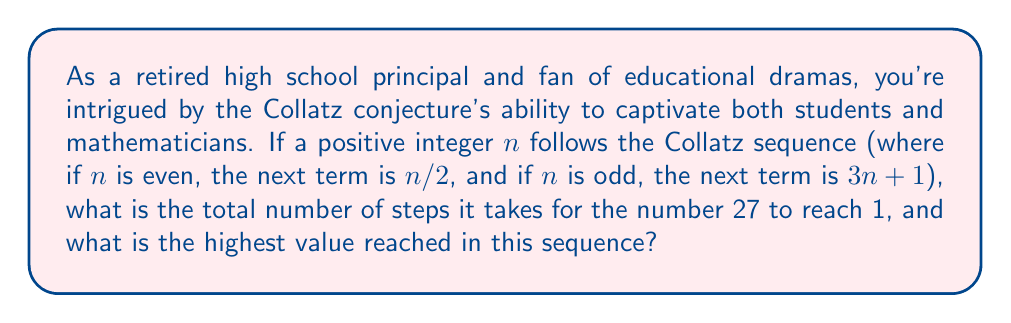Solve this math problem. Let's work through the Collatz sequence for 27:

1) Start with $n = 27$ (odd)
2) $3n + 1 = 3(27) + 1 = 82$
3) $82/2 = 41$ (even)
4) $3(41) + 1 = 124$
5) $124/2 = 62$
6) $62/2 = 31$
7) $3(31) + 1 = 94$
8) $94/2 = 47$
9) $3(47) + 1 = 142$
10) $142/2 = 71$
11) $3(71) + 1 = 214$
12) $214/2 = 107$
13) $3(107) + 1 = 322$
14) $322/2 = 161$
15) $3(161) + 1 = 484$
16) $484/2 = 242$
17) $242/2 = 121$
18) $3(121) + 1 = 364$
19) $364/2 = 182$
20) $182/2 = 91$
21) $3(91) + 1 = 274$
22) $274/2 = 137$
23) $3(137) + 1 = 412$
24) $412/2 = 206$
25) $206/2 = 103$
26) $3(103) + 1 = 310$
27) $310/2 = 155$
28) $3(155) + 1 = 466$
29) $466/2 = 233$
30) $3(233) + 1 = 700$
31) $700/2 = 350$
32) $350/2 = 175$
33) $3(175) + 1 = 526$
34) $526/2 = 263$
35) $3(263) + 1 = 790$
36) $790/2 = 395$
37) $3(395) + 1 = 1186$
38) $1186/2 = 593$
39) $3(593) + 1 = 1780$
40) $1780/2 = 890$
41) $890/2 = 445$
42) $3(445) + 1 = 1336$
43) $1336/2 = 668$
44) $668/2 = 334$
45) $334/2 = 167$
46) $3(167) + 1 = 502$
47) $502/2 = 251$
48) $3(251) + 1 = 754$
49) $754/2 = 377$
50) $3(377) + 1 = 1132$
51) $1132/2 = 566$
52) $566/2 = 283$
53) $3(283) + 1 = 850$
54) $850/2 = 425$
55) $3(425) + 1 = 1276$
56) $1276/2 = 638$
57) $638/2 = 319$
58) $3(319) + 1 = 958$
59) $958/2 = 479$
60) $3(479) + 1 = 1438$
61) $1438/2 = 719$
62) $3(719) + 1 = 2158$
63) $2158/2 = 1079$
64) $3(1079) + 1 = 3238$
65) $3238/2 = 1619$
66) $3(1619) + 1 = 4858$
67) $4858/2 = 2429$
68) $3(2429) + 1 = 7288$
69) $7288/2 = 3644$
70) $3644/2 = 1822$
71) $1822/2 = 911$
72) $3(911) + 1 = 2734$
73) $2734/2 = 1367$
74) $3(1367) + 1 = 4102$
75) $4102/2 = 2051$
76) $3(2051) + 1 = 6154$
77) $6154/2 = 3077$
78) $3(3077) + 1 = 9232$
79) $9232/2 = 4616$
80) $4616/2 = 2308$
81) $2308/2 = 1154$
82) $1154/2 = 577$
83) $3(577) + 1 = 1732$
84) $1732/2 = 866$
85) $866/2 = 433$
86) $3(433) + 1 = 1300$
87) $1300/2 = 650$
88) $650/2 = 325$
89) $3(325) + 1 = 976$
90) $976/2 = 488$
91) $488/2 = 244$
92) $244/2 = 122$
93) $122/2 = 61$
94) $3(61) + 1 = 184$
95) $184/2 = 92$
96) $92/2 = 46$
97) $46/2 = 23$
98) $3(23) + 1 = 70$
99) $70/2 = 35$
100) $3(35) + 1 = 106$
101) $106/2 = 53$
102) $3(53) + 1 = 160$
103) $160/2 = 80$
104) $80/2 = 40$
105) $40/2 = 20$
106) $20/2 = 10$
107) $10/2 = 5$
108) $3(5) + 1 = 16$
109) $16/2 = 8$
110) $8/2 = 4$
111) $4/2 = 2$
112) $2/2 = 1$

The sequence reaches 1 after 111 steps.

The highest value reached in this sequence is 9232.
Answer: The number 27 takes 111 steps to reach 1 in the Collatz sequence, and the highest value reached is 9232. 